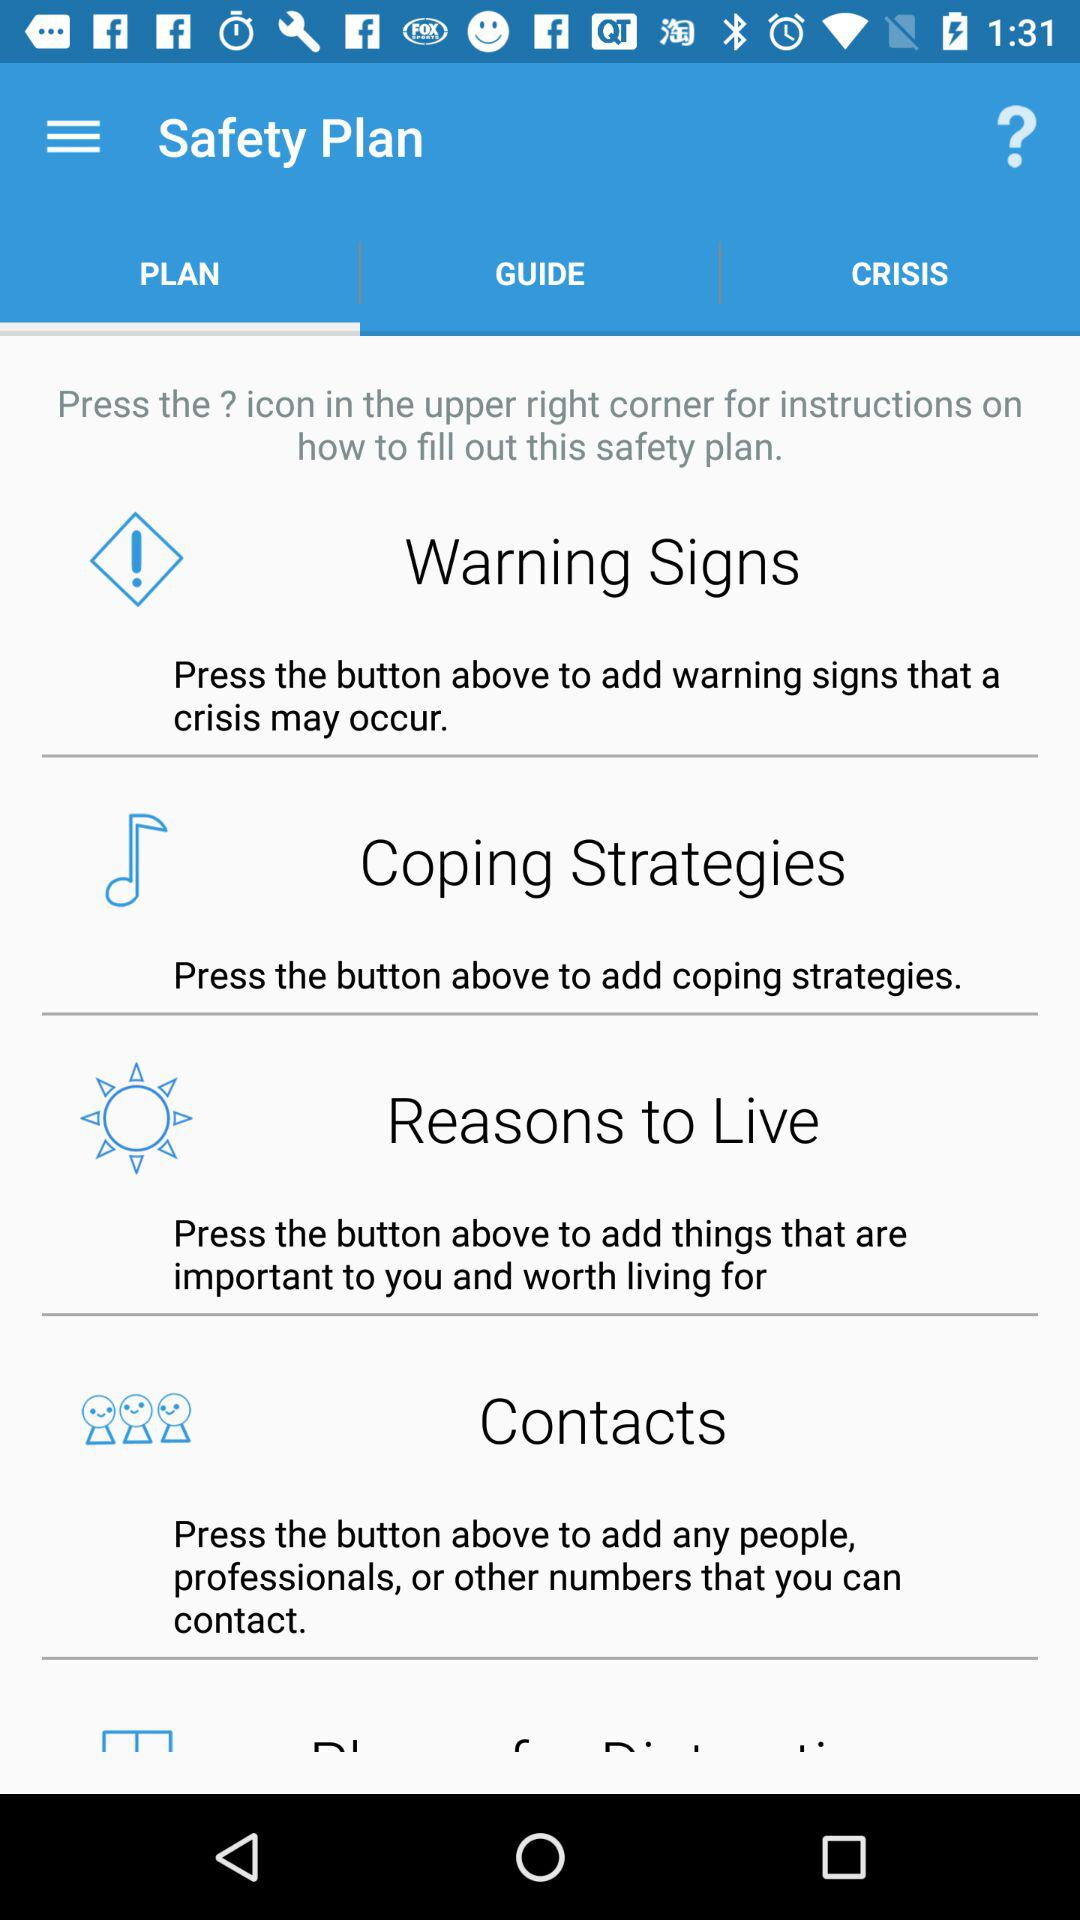Which tab is selected? The selected tab is "PLAN". 